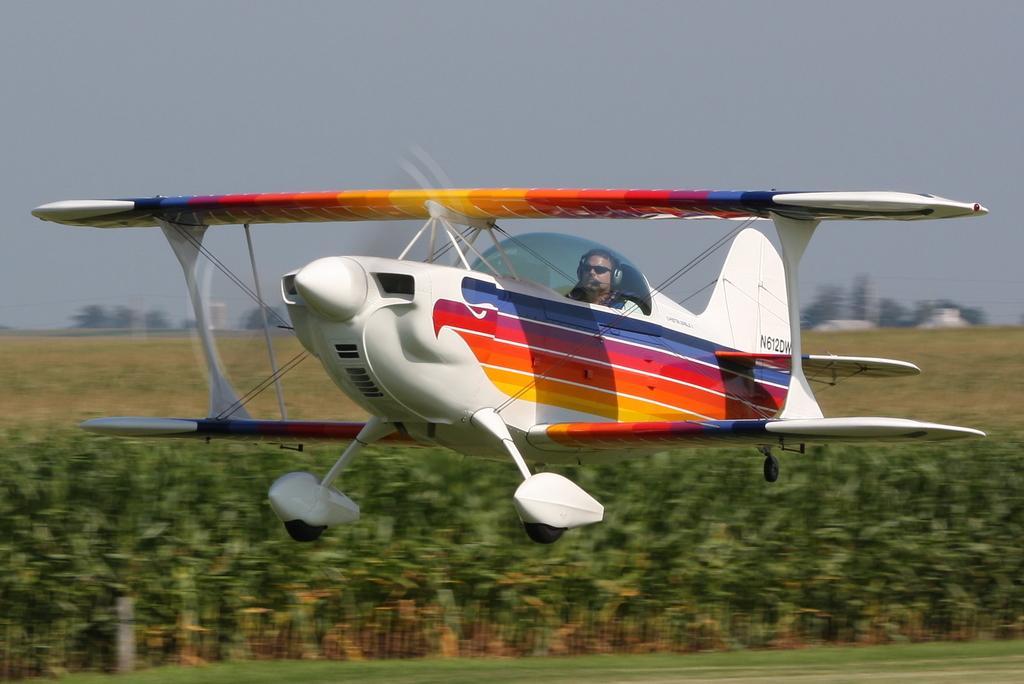Can you describe this image briefly? This picture is clicked outside the city. In the center there is a person flying an airplane in the air. In the foreground we can see the green grass and the plants. In the background there is a sky and the trees. 